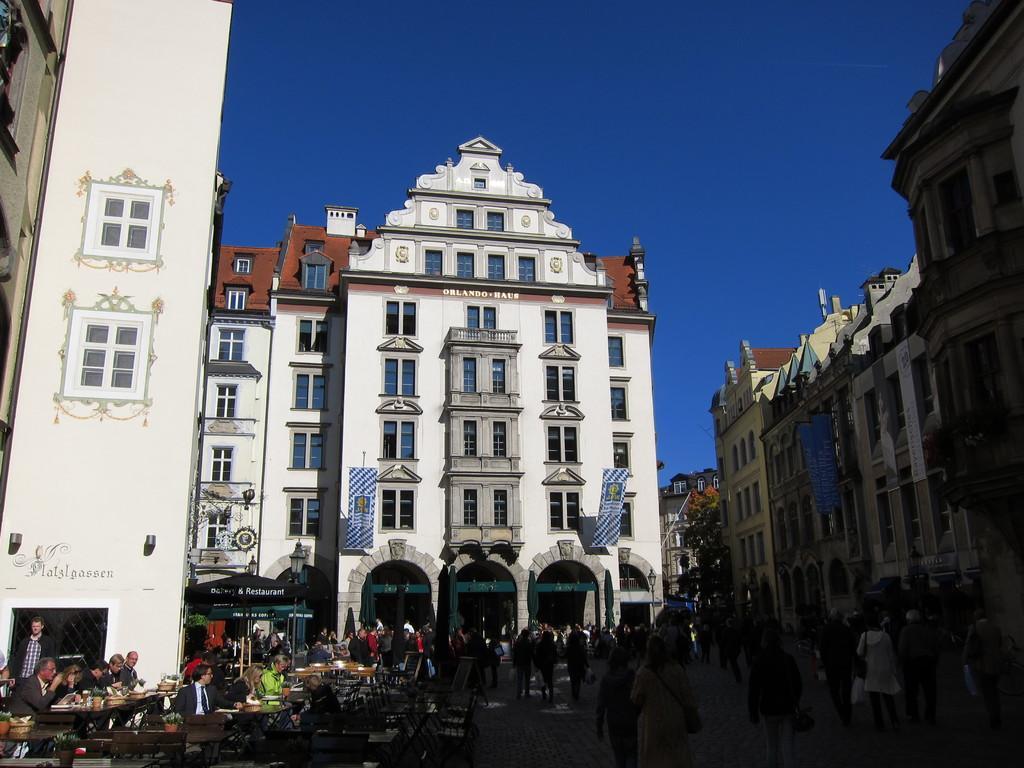Could you give a brief overview of what you see in this image? In the background we can see the sky. In this picture we can see the buildings, windows, banners, trees, road and the people. On the left side of the picture we can see the people, chairs and the tables. Few are sitting on the chairs and on the tables we can see few objects. We can see a pot and a plant. 